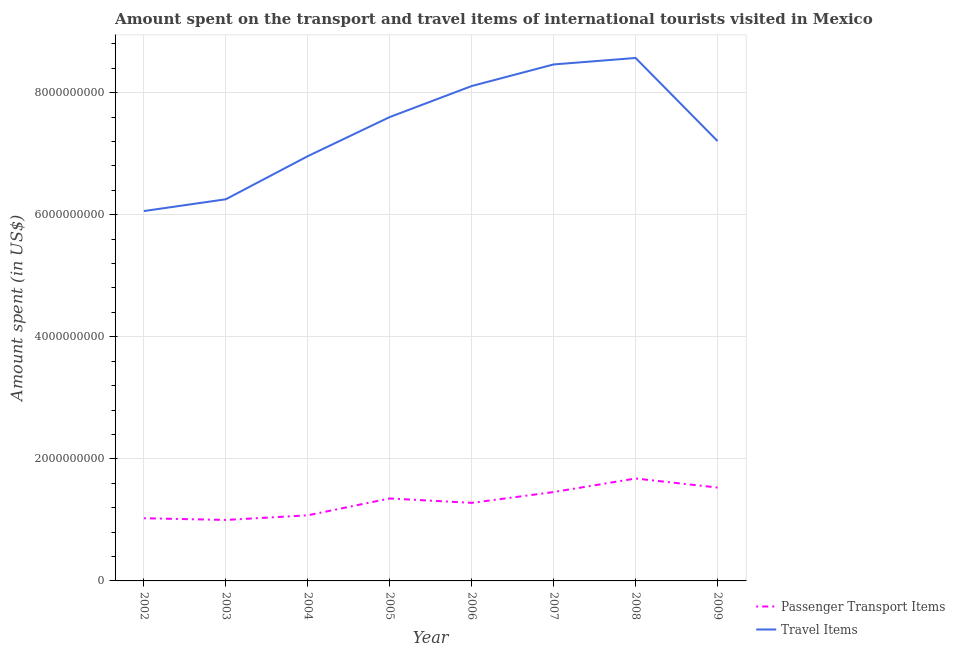Does the line corresponding to amount spent in travel items intersect with the line corresponding to amount spent on passenger transport items?
Your answer should be compact. No. What is the amount spent on passenger transport items in 2002?
Give a very brief answer. 1.03e+09. Across all years, what is the maximum amount spent in travel items?
Offer a very short reply. 8.57e+09. Across all years, what is the minimum amount spent on passenger transport items?
Provide a short and direct response. 9.99e+08. In which year was the amount spent on passenger transport items minimum?
Your answer should be very brief. 2003. What is the total amount spent on passenger transport items in the graph?
Keep it short and to the point. 1.04e+1. What is the difference between the amount spent in travel items in 2002 and that in 2005?
Provide a short and direct response. -1.54e+09. What is the difference between the amount spent on passenger transport items in 2008 and the amount spent in travel items in 2009?
Give a very brief answer. -5.53e+09. What is the average amount spent on passenger transport items per year?
Make the answer very short. 1.30e+09. In the year 2009, what is the difference between the amount spent in travel items and amount spent on passenger transport items?
Offer a terse response. 5.68e+09. What is the ratio of the amount spent on passenger transport items in 2002 to that in 2003?
Keep it short and to the point. 1.03. Is the amount spent in travel items in 2003 less than that in 2006?
Make the answer very short. Yes. What is the difference between the highest and the second highest amount spent in travel items?
Keep it short and to the point. 1.06e+08. What is the difference between the highest and the lowest amount spent in travel items?
Your response must be concise. 2.51e+09. Are the values on the major ticks of Y-axis written in scientific E-notation?
Your answer should be very brief. No. Does the graph contain grids?
Keep it short and to the point. Yes. What is the title of the graph?
Ensure brevity in your answer.  Amount spent on the transport and travel items of international tourists visited in Mexico. What is the label or title of the Y-axis?
Make the answer very short. Amount spent (in US$). What is the Amount spent (in US$) in Passenger Transport Items in 2002?
Your answer should be compact. 1.03e+09. What is the Amount spent (in US$) of Travel Items in 2002?
Keep it short and to the point. 6.06e+09. What is the Amount spent (in US$) in Passenger Transport Items in 2003?
Your response must be concise. 9.99e+08. What is the Amount spent (in US$) in Travel Items in 2003?
Provide a short and direct response. 6.25e+09. What is the Amount spent (in US$) in Passenger Transport Items in 2004?
Your answer should be very brief. 1.08e+09. What is the Amount spent (in US$) in Travel Items in 2004?
Offer a terse response. 6.96e+09. What is the Amount spent (in US$) in Passenger Transport Items in 2005?
Your response must be concise. 1.35e+09. What is the Amount spent (in US$) of Travel Items in 2005?
Provide a short and direct response. 7.60e+09. What is the Amount spent (in US$) in Passenger Transport Items in 2006?
Offer a terse response. 1.28e+09. What is the Amount spent (in US$) in Travel Items in 2006?
Give a very brief answer. 8.11e+09. What is the Amount spent (in US$) of Passenger Transport Items in 2007?
Your response must be concise. 1.46e+09. What is the Amount spent (in US$) in Travel Items in 2007?
Your response must be concise. 8.46e+09. What is the Amount spent (in US$) in Passenger Transport Items in 2008?
Provide a succinct answer. 1.68e+09. What is the Amount spent (in US$) in Travel Items in 2008?
Offer a very short reply. 8.57e+09. What is the Amount spent (in US$) of Passenger Transport Items in 2009?
Make the answer very short. 1.53e+09. What is the Amount spent (in US$) in Travel Items in 2009?
Give a very brief answer. 7.21e+09. Across all years, what is the maximum Amount spent (in US$) in Passenger Transport Items?
Make the answer very short. 1.68e+09. Across all years, what is the maximum Amount spent (in US$) in Travel Items?
Offer a terse response. 8.57e+09. Across all years, what is the minimum Amount spent (in US$) of Passenger Transport Items?
Make the answer very short. 9.99e+08. Across all years, what is the minimum Amount spent (in US$) of Travel Items?
Your response must be concise. 6.06e+09. What is the total Amount spent (in US$) of Passenger Transport Items in the graph?
Your response must be concise. 1.04e+1. What is the total Amount spent (in US$) in Travel Items in the graph?
Provide a succinct answer. 5.92e+1. What is the difference between the Amount spent (in US$) in Passenger Transport Items in 2002 and that in 2003?
Provide a succinct answer. 2.80e+07. What is the difference between the Amount spent (in US$) of Travel Items in 2002 and that in 2003?
Your response must be concise. -1.93e+08. What is the difference between the Amount spent (in US$) of Passenger Transport Items in 2002 and that in 2004?
Offer a terse response. -4.80e+07. What is the difference between the Amount spent (in US$) of Travel Items in 2002 and that in 2004?
Your answer should be compact. -8.99e+08. What is the difference between the Amount spent (in US$) in Passenger Transport Items in 2002 and that in 2005?
Provide a succinct answer. -3.24e+08. What is the difference between the Amount spent (in US$) in Travel Items in 2002 and that in 2005?
Offer a terse response. -1.54e+09. What is the difference between the Amount spent (in US$) of Passenger Transport Items in 2002 and that in 2006?
Your response must be concise. -2.52e+08. What is the difference between the Amount spent (in US$) in Travel Items in 2002 and that in 2006?
Your answer should be very brief. -2.05e+09. What is the difference between the Amount spent (in US$) of Passenger Transport Items in 2002 and that in 2007?
Ensure brevity in your answer.  -4.29e+08. What is the difference between the Amount spent (in US$) in Travel Items in 2002 and that in 2007?
Keep it short and to the point. -2.40e+09. What is the difference between the Amount spent (in US$) in Passenger Transport Items in 2002 and that in 2008?
Your answer should be very brief. -6.51e+08. What is the difference between the Amount spent (in US$) in Travel Items in 2002 and that in 2008?
Provide a succinct answer. -2.51e+09. What is the difference between the Amount spent (in US$) of Passenger Transport Items in 2002 and that in 2009?
Give a very brief answer. -5.03e+08. What is the difference between the Amount spent (in US$) in Travel Items in 2002 and that in 2009?
Your answer should be compact. -1.15e+09. What is the difference between the Amount spent (in US$) in Passenger Transport Items in 2003 and that in 2004?
Your response must be concise. -7.60e+07. What is the difference between the Amount spent (in US$) in Travel Items in 2003 and that in 2004?
Give a very brief answer. -7.06e+08. What is the difference between the Amount spent (in US$) in Passenger Transport Items in 2003 and that in 2005?
Your answer should be very brief. -3.52e+08. What is the difference between the Amount spent (in US$) in Travel Items in 2003 and that in 2005?
Ensure brevity in your answer.  -1.35e+09. What is the difference between the Amount spent (in US$) in Passenger Transport Items in 2003 and that in 2006?
Provide a succinct answer. -2.80e+08. What is the difference between the Amount spent (in US$) in Travel Items in 2003 and that in 2006?
Ensure brevity in your answer.  -1.86e+09. What is the difference between the Amount spent (in US$) in Passenger Transport Items in 2003 and that in 2007?
Give a very brief answer. -4.57e+08. What is the difference between the Amount spent (in US$) of Travel Items in 2003 and that in 2007?
Your response must be concise. -2.21e+09. What is the difference between the Amount spent (in US$) in Passenger Transport Items in 2003 and that in 2008?
Offer a terse response. -6.79e+08. What is the difference between the Amount spent (in US$) in Travel Items in 2003 and that in 2008?
Offer a very short reply. -2.32e+09. What is the difference between the Amount spent (in US$) of Passenger Transport Items in 2003 and that in 2009?
Provide a short and direct response. -5.31e+08. What is the difference between the Amount spent (in US$) in Travel Items in 2003 and that in 2009?
Provide a succinct answer. -9.54e+08. What is the difference between the Amount spent (in US$) in Passenger Transport Items in 2004 and that in 2005?
Offer a terse response. -2.76e+08. What is the difference between the Amount spent (in US$) in Travel Items in 2004 and that in 2005?
Provide a succinct answer. -6.41e+08. What is the difference between the Amount spent (in US$) of Passenger Transport Items in 2004 and that in 2006?
Offer a terse response. -2.04e+08. What is the difference between the Amount spent (in US$) in Travel Items in 2004 and that in 2006?
Provide a succinct answer. -1.15e+09. What is the difference between the Amount spent (in US$) in Passenger Transport Items in 2004 and that in 2007?
Your response must be concise. -3.81e+08. What is the difference between the Amount spent (in US$) in Travel Items in 2004 and that in 2007?
Make the answer very short. -1.50e+09. What is the difference between the Amount spent (in US$) of Passenger Transport Items in 2004 and that in 2008?
Offer a very short reply. -6.03e+08. What is the difference between the Amount spent (in US$) of Travel Items in 2004 and that in 2008?
Your answer should be very brief. -1.61e+09. What is the difference between the Amount spent (in US$) of Passenger Transport Items in 2004 and that in 2009?
Keep it short and to the point. -4.55e+08. What is the difference between the Amount spent (in US$) of Travel Items in 2004 and that in 2009?
Offer a very short reply. -2.48e+08. What is the difference between the Amount spent (in US$) of Passenger Transport Items in 2005 and that in 2006?
Provide a succinct answer. 7.20e+07. What is the difference between the Amount spent (in US$) of Travel Items in 2005 and that in 2006?
Make the answer very short. -5.08e+08. What is the difference between the Amount spent (in US$) of Passenger Transport Items in 2005 and that in 2007?
Your answer should be very brief. -1.05e+08. What is the difference between the Amount spent (in US$) of Travel Items in 2005 and that in 2007?
Your answer should be very brief. -8.62e+08. What is the difference between the Amount spent (in US$) of Passenger Transport Items in 2005 and that in 2008?
Your answer should be very brief. -3.27e+08. What is the difference between the Amount spent (in US$) in Travel Items in 2005 and that in 2008?
Offer a very short reply. -9.68e+08. What is the difference between the Amount spent (in US$) in Passenger Transport Items in 2005 and that in 2009?
Offer a very short reply. -1.79e+08. What is the difference between the Amount spent (in US$) of Travel Items in 2005 and that in 2009?
Make the answer very short. 3.93e+08. What is the difference between the Amount spent (in US$) in Passenger Transport Items in 2006 and that in 2007?
Offer a very short reply. -1.77e+08. What is the difference between the Amount spent (in US$) of Travel Items in 2006 and that in 2007?
Provide a short and direct response. -3.54e+08. What is the difference between the Amount spent (in US$) of Passenger Transport Items in 2006 and that in 2008?
Your answer should be very brief. -3.99e+08. What is the difference between the Amount spent (in US$) in Travel Items in 2006 and that in 2008?
Offer a very short reply. -4.60e+08. What is the difference between the Amount spent (in US$) of Passenger Transport Items in 2006 and that in 2009?
Your response must be concise. -2.51e+08. What is the difference between the Amount spent (in US$) of Travel Items in 2006 and that in 2009?
Make the answer very short. 9.01e+08. What is the difference between the Amount spent (in US$) in Passenger Transport Items in 2007 and that in 2008?
Offer a very short reply. -2.22e+08. What is the difference between the Amount spent (in US$) of Travel Items in 2007 and that in 2008?
Keep it short and to the point. -1.06e+08. What is the difference between the Amount spent (in US$) in Passenger Transport Items in 2007 and that in 2009?
Keep it short and to the point. -7.40e+07. What is the difference between the Amount spent (in US$) of Travel Items in 2007 and that in 2009?
Keep it short and to the point. 1.26e+09. What is the difference between the Amount spent (in US$) of Passenger Transport Items in 2008 and that in 2009?
Provide a short and direct response. 1.48e+08. What is the difference between the Amount spent (in US$) of Travel Items in 2008 and that in 2009?
Make the answer very short. 1.36e+09. What is the difference between the Amount spent (in US$) of Passenger Transport Items in 2002 and the Amount spent (in US$) of Travel Items in 2003?
Make the answer very short. -5.23e+09. What is the difference between the Amount spent (in US$) of Passenger Transport Items in 2002 and the Amount spent (in US$) of Travel Items in 2004?
Provide a short and direct response. -5.93e+09. What is the difference between the Amount spent (in US$) in Passenger Transport Items in 2002 and the Amount spent (in US$) in Travel Items in 2005?
Provide a succinct answer. -6.57e+09. What is the difference between the Amount spent (in US$) in Passenger Transport Items in 2002 and the Amount spent (in US$) in Travel Items in 2006?
Make the answer very short. -7.08e+09. What is the difference between the Amount spent (in US$) in Passenger Transport Items in 2002 and the Amount spent (in US$) in Travel Items in 2007?
Your response must be concise. -7.44e+09. What is the difference between the Amount spent (in US$) of Passenger Transport Items in 2002 and the Amount spent (in US$) of Travel Items in 2008?
Provide a succinct answer. -7.54e+09. What is the difference between the Amount spent (in US$) in Passenger Transport Items in 2002 and the Amount spent (in US$) in Travel Items in 2009?
Make the answer very short. -6.18e+09. What is the difference between the Amount spent (in US$) in Passenger Transport Items in 2003 and the Amount spent (in US$) in Travel Items in 2004?
Your answer should be very brief. -5.96e+09. What is the difference between the Amount spent (in US$) of Passenger Transport Items in 2003 and the Amount spent (in US$) of Travel Items in 2005?
Provide a succinct answer. -6.60e+09. What is the difference between the Amount spent (in US$) in Passenger Transport Items in 2003 and the Amount spent (in US$) in Travel Items in 2006?
Keep it short and to the point. -7.11e+09. What is the difference between the Amount spent (in US$) of Passenger Transport Items in 2003 and the Amount spent (in US$) of Travel Items in 2007?
Offer a terse response. -7.46e+09. What is the difference between the Amount spent (in US$) in Passenger Transport Items in 2003 and the Amount spent (in US$) in Travel Items in 2008?
Keep it short and to the point. -7.57e+09. What is the difference between the Amount spent (in US$) in Passenger Transport Items in 2003 and the Amount spent (in US$) in Travel Items in 2009?
Ensure brevity in your answer.  -6.21e+09. What is the difference between the Amount spent (in US$) in Passenger Transport Items in 2004 and the Amount spent (in US$) in Travel Items in 2005?
Offer a terse response. -6.52e+09. What is the difference between the Amount spent (in US$) of Passenger Transport Items in 2004 and the Amount spent (in US$) of Travel Items in 2006?
Give a very brief answer. -7.03e+09. What is the difference between the Amount spent (in US$) of Passenger Transport Items in 2004 and the Amount spent (in US$) of Travel Items in 2007?
Keep it short and to the point. -7.39e+09. What is the difference between the Amount spent (in US$) of Passenger Transport Items in 2004 and the Amount spent (in US$) of Travel Items in 2008?
Provide a short and direct response. -7.49e+09. What is the difference between the Amount spent (in US$) in Passenger Transport Items in 2004 and the Amount spent (in US$) in Travel Items in 2009?
Keep it short and to the point. -6.13e+09. What is the difference between the Amount spent (in US$) of Passenger Transport Items in 2005 and the Amount spent (in US$) of Travel Items in 2006?
Provide a succinct answer. -6.76e+09. What is the difference between the Amount spent (in US$) in Passenger Transport Items in 2005 and the Amount spent (in US$) in Travel Items in 2007?
Make the answer very short. -7.11e+09. What is the difference between the Amount spent (in US$) in Passenger Transport Items in 2005 and the Amount spent (in US$) in Travel Items in 2008?
Your answer should be compact. -7.22e+09. What is the difference between the Amount spent (in US$) of Passenger Transport Items in 2005 and the Amount spent (in US$) of Travel Items in 2009?
Your response must be concise. -5.86e+09. What is the difference between the Amount spent (in US$) of Passenger Transport Items in 2006 and the Amount spent (in US$) of Travel Items in 2007?
Provide a short and direct response. -7.18e+09. What is the difference between the Amount spent (in US$) in Passenger Transport Items in 2006 and the Amount spent (in US$) in Travel Items in 2008?
Provide a succinct answer. -7.29e+09. What is the difference between the Amount spent (in US$) in Passenger Transport Items in 2006 and the Amount spent (in US$) in Travel Items in 2009?
Keep it short and to the point. -5.93e+09. What is the difference between the Amount spent (in US$) in Passenger Transport Items in 2007 and the Amount spent (in US$) in Travel Items in 2008?
Give a very brief answer. -7.11e+09. What is the difference between the Amount spent (in US$) of Passenger Transport Items in 2007 and the Amount spent (in US$) of Travel Items in 2009?
Keep it short and to the point. -5.75e+09. What is the difference between the Amount spent (in US$) in Passenger Transport Items in 2008 and the Amount spent (in US$) in Travel Items in 2009?
Your answer should be compact. -5.53e+09. What is the average Amount spent (in US$) in Passenger Transport Items per year?
Give a very brief answer. 1.30e+09. What is the average Amount spent (in US$) of Travel Items per year?
Provide a short and direct response. 7.40e+09. In the year 2002, what is the difference between the Amount spent (in US$) of Passenger Transport Items and Amount spent (in US$) of Travel Items?
Your response must be concise. -5.03e+09. In the year 2003, what is the difference between the Amount spent (in US$) of Passenger Transport Items and Amount spent (in US$) of Travel Items?
Provide a succinct answer. -5.25e+09. In the year 2004, what is the difference between the Amount spent (in US$) of Passenger Transport Items and Amount spent (in US$) of Travel Items?
Keep it short and to the point. -5.88e+09. In the year 2005, what is the difference between the Amount spent (in US$) of Passenger Transport Items and Amount spent (in US$) of Travel Items?
Provide a short and direct response. -6.25e+09. In the year 2006, what is the difference between the Amount spent (in US$) of Passenger Transport Items and Amount spent (in US$) of Travel Items?
Your answer should be compact. -6.83e+09. In the year 2007, what is the difference between the Amount spent (in US$) in Passenger Transport Items and Amount spent (in US$) in Travel Items?
Give a very brief answer. -7.01e+09. In the year 2008, what is the difference between the Amount spent (in US$) of Passenger Transport Items and Amount spent (in US$) of Travel Items?
Offer a terse response. -6.89e+09. In the year 2009, what is the difference between the Amount spent (in US$) in Passenger Transport Items and Amount spent (in US$) in Travel Items?
Give a very brief answer. -5.68e+09. What is the ratio of the Amount spent (in US$) in Passenger Transport Items in 2002 to that in 2003?
Offer a terse response. 1.03. What is the ratio of the Amount spent (in US$) in Travel Items in 2002 to that in 2003?
Keep it short and to the point. 0.97. What is the ratio of the Amount spent (in US$) of Passenger Transport Items in 2002 to that in 2004?
Your answer should be compact. 0.96. What is the ratio of the Amount spent (in US$) in Travel Items in 2002 to that in 2004?
Ensure brevity in your answer.  0.87. What is the ratio of the Amount spent (in US$) in Passenger Transport Items in 2002 to that in 2005?
Offer a terse response. 0.76. What is the ratio of the Amount spent (in US$) in Travel Items in 2002 to that in 2005?
Your answer should be very brief. 0.8. What is the ratio of the Amount spent (in US$) of Passenger Transport Items in 2002 to that in 2006?
Offer a very short reply. 0.8. What is the ratio of the Amount spent (in US$) of Travel Items in 2002 to that in 2006?
Ensure brevity in your answer.  0.75. What is the ratio of the Amount spent (in US$) in Passenger Transport Items in 2002 to that in 2007?
Offer a terse response. 0.71. What is the ratio of the Amount spent (in US$) in Travel Items in 2002 to that in 2007?
Your answer should be compact. 0.72. What is the ratio of the Amount spent (in US$) of Passenger Transport Items in 2002 to that in 2008?
Your response must be concise. 0.61. What is the ratio of the Amount spent (in US$) in Travel Items in 2002 to that in 2008?
Offer a terse response. 0.71. What is the ratio of the Amount spent (in US$) of Passenger Transport Items in 2002 to that in 2009?
Keep it short and to the point. 0.67. What is the ratio of the Amount spent (in US$) of Travel Items in 2002 to that in 2009?
Keep it short and to the point. 0.84. What is the ratio of the Amount spent (in US$) in Passenger Transport Items in 2003 to that in 2004?
Your answer should be compact. 0.93. What is the ratio of the Amount spent (in US$) in Travel Items in 2003 to that in 2004?
Offer a very short reply. 0.9. What is the ratio of the Amount spent (in US$) of Passenger Transport Items in 2003 to that in 2005?
Make the answer very short. 0.74. What is the ratio of the Amount spent (in US$) of Travel Items in 2003 to that in 2005?
Provide a short and direct response. 0.82. What is the ratio of the Amount spent (in US$) of Passenger Transport Items in 2003 to that in 2006?
Give a very brief answer. 0.78. What is the ratio of the Amount spent (in US$) in Travel Items in 2003 to that in 2006?
Ensure brevity in your answer.  0.77. What is the ratio of the Amount spent (in US$) in Passenger Transport Items in 2003 to that in 2007?
Provide a short and direct response. 0.69. What is the ratio of the Amount spent (in US$) in Travel Items in 2003 to that in 2007?
Ensure brevity in your answer.  0.74. What is the ratio of the Amount spent (in US$) of Passenger Transport Items in 2003 to that in 2008?
Offer a very short reply. 0.6. What is the ratio of the Amount spent (in US$) of Travel Items in 2003 to that in 2008?
Your response must be concise. 0.73. What is the ratio of the Amount spent (in US$) of Passenger Transport Items in 2003 to that in 2009?
Your answer should be very brief. 0.65. What is the ratio of the Amount spent (in US$) of Travel Items in 2003 to that in 2009?
Keep it short and to the point. 0.87. What is the ratio of the Amount spent (in US$) in Passenger Transport Items in 2004 to that in 2005?
Provide a succinct answer. 0.8. What is the ratio of the Amount spent (in US$) of Travel Items in 2004 to that in 2005?
Provide a short and direct response. 0.92. What is the ratio of the Amount spent (in US$) of Passenger Transport Items in 2004 to that in 2006?
Keep it short and to the point. 0.84. What is the ratio of the Amount spent (in US$) in Travel Items in 2004 to that in 2006?
Keep it short and to the point. 0.86. What is the ratio of the Amount spent (in US$) in Passenger Transport Items in 2004 to that in 2007?
Make the answer very short. 0.74. What is the ratio of the Amount spent (in US$) in Travel Items in 2004 to that in 2007?
Ensure brevity in your answer.  0.82. What is the ratio of the Amount spent (in US$) of Passenger Transport Items in 2004 to that in 2008?
Provide a short and direct response. 0.64. What is the ratio of the Amount spent (in US$) of Travel Items in 2004 to that in 2008?
Ensure brevity in your answer.  0.81. What is the ratio of the Amount spent (in US$) of Passenger Transport Items in 2004 to that in 2009?
Give a very brief answer. 0.7. What is the ratio of the Amount spent (in US$) in Travel Items in 2004 to that in 2009?
Make the answer very short. 0.97. What is the ratio of the Amount spent (in US$) in Passenger Transport Items in 2005 to that in 2006?
Ensure brevity in your answer.  1.06. What is the ratio of the Amount spent (in US$) of Travel Items in 2005 to that in 2006?
Your response must be concise. 0.94. What is the ratio of the Amount spent (in US$) in Passenger Transport Items in 2005 to that in 2007?
Provide a succinct answer. 0.93. What is the ratio of the Amount spent (in US$) in Travel Items in 2005 to that in 2007?
Give a very brief answer. 0.9. What is the ratio of the Amount spent (in US$) in Passenger Transport Items in 2005 to that in 2008?
Offer a terse response. 0.81. What is the ratio of the Amount spent (in US$) in Travel Items in 2005 to that in 2008?
Your response must be concise. 0.89. What is the ratio of the Amount spent (in US$) of Passenger Transport Items in 2005 to that in 2009?
Ensure brevity in your answer.  0.88. What is the ratio of the Amount spent (in US$) of Travel Items in 2005 to that in 2009?
Your answer should be very brief. 1.05. What is the ratio of the Amount spent (in US$) in Passenger Transport Items in 2006 to that in 2007?
Give a very brief answer. 0.88. What is the ratio of the Amount spent (in US$) in Travel Items in 2006 to that in 2007?
Make the answer very short. 0.96. What is the ratio of the Amount spent (in US$) of Passenger Transport Items in 2006 to that in 2008?
Keep it short and to the point. 0.76. What is the ratio of the Amount spent (in US$) of Travel Items in 2006 to that in 2008?
Your answer should be compact. 0.95. What is the ratio of the Amount spent (in US$) in Passenger Transport Items in 2006 to that in 2009?
Offer a very short reply. 0.84. What is the ratio of the Amount spent (in US$) of Passenger Transport Items in 2007 to that in 2008?
Your response must be concise. 0.87. What is the ratio of the Amount spent (in US$) in Travel Items in 2007 to that in 2008?
Give a very brief answer. 0.99. What is the ratio of the Amount spent (in US$) of Passenger Transport Items in 2007 to that in 2009?
Provide a short and direct response. 0.95. What is the ratio of the Amount spent (in US$) in Travel Items in 2007 to that in 2009?
Ensure brevity in your answer.  1.17. What is the ratio of the Amount spent (in US$) of Passenger Transport Items in 2008 to that in 2009?
Keep it short and to the point. 1.1. What is the ratio of the Amount spent (in US$) in Travel Items in 2008 to that in 2009?
Give a very brief answer. 1.19. What is the difference between the highest and the second highest Amount spent (in US$) in Passenger Transport Items?
Your response must be concise. 1.48e+08. What is the difference between the highest and the second highest Amount spent (in US$) in Travel Items?
Your response must be concise. 1.06e+08. What is the difference between the highest and the lowest Amount spent (in US$) in Passenger Transport Items?
Provide a succinct answer. 6.79e+08. What is the difference between the highest and the lowest Amount spent (in US$) of Travel Items?
Provide a short and direct response. 2.51e+09. 